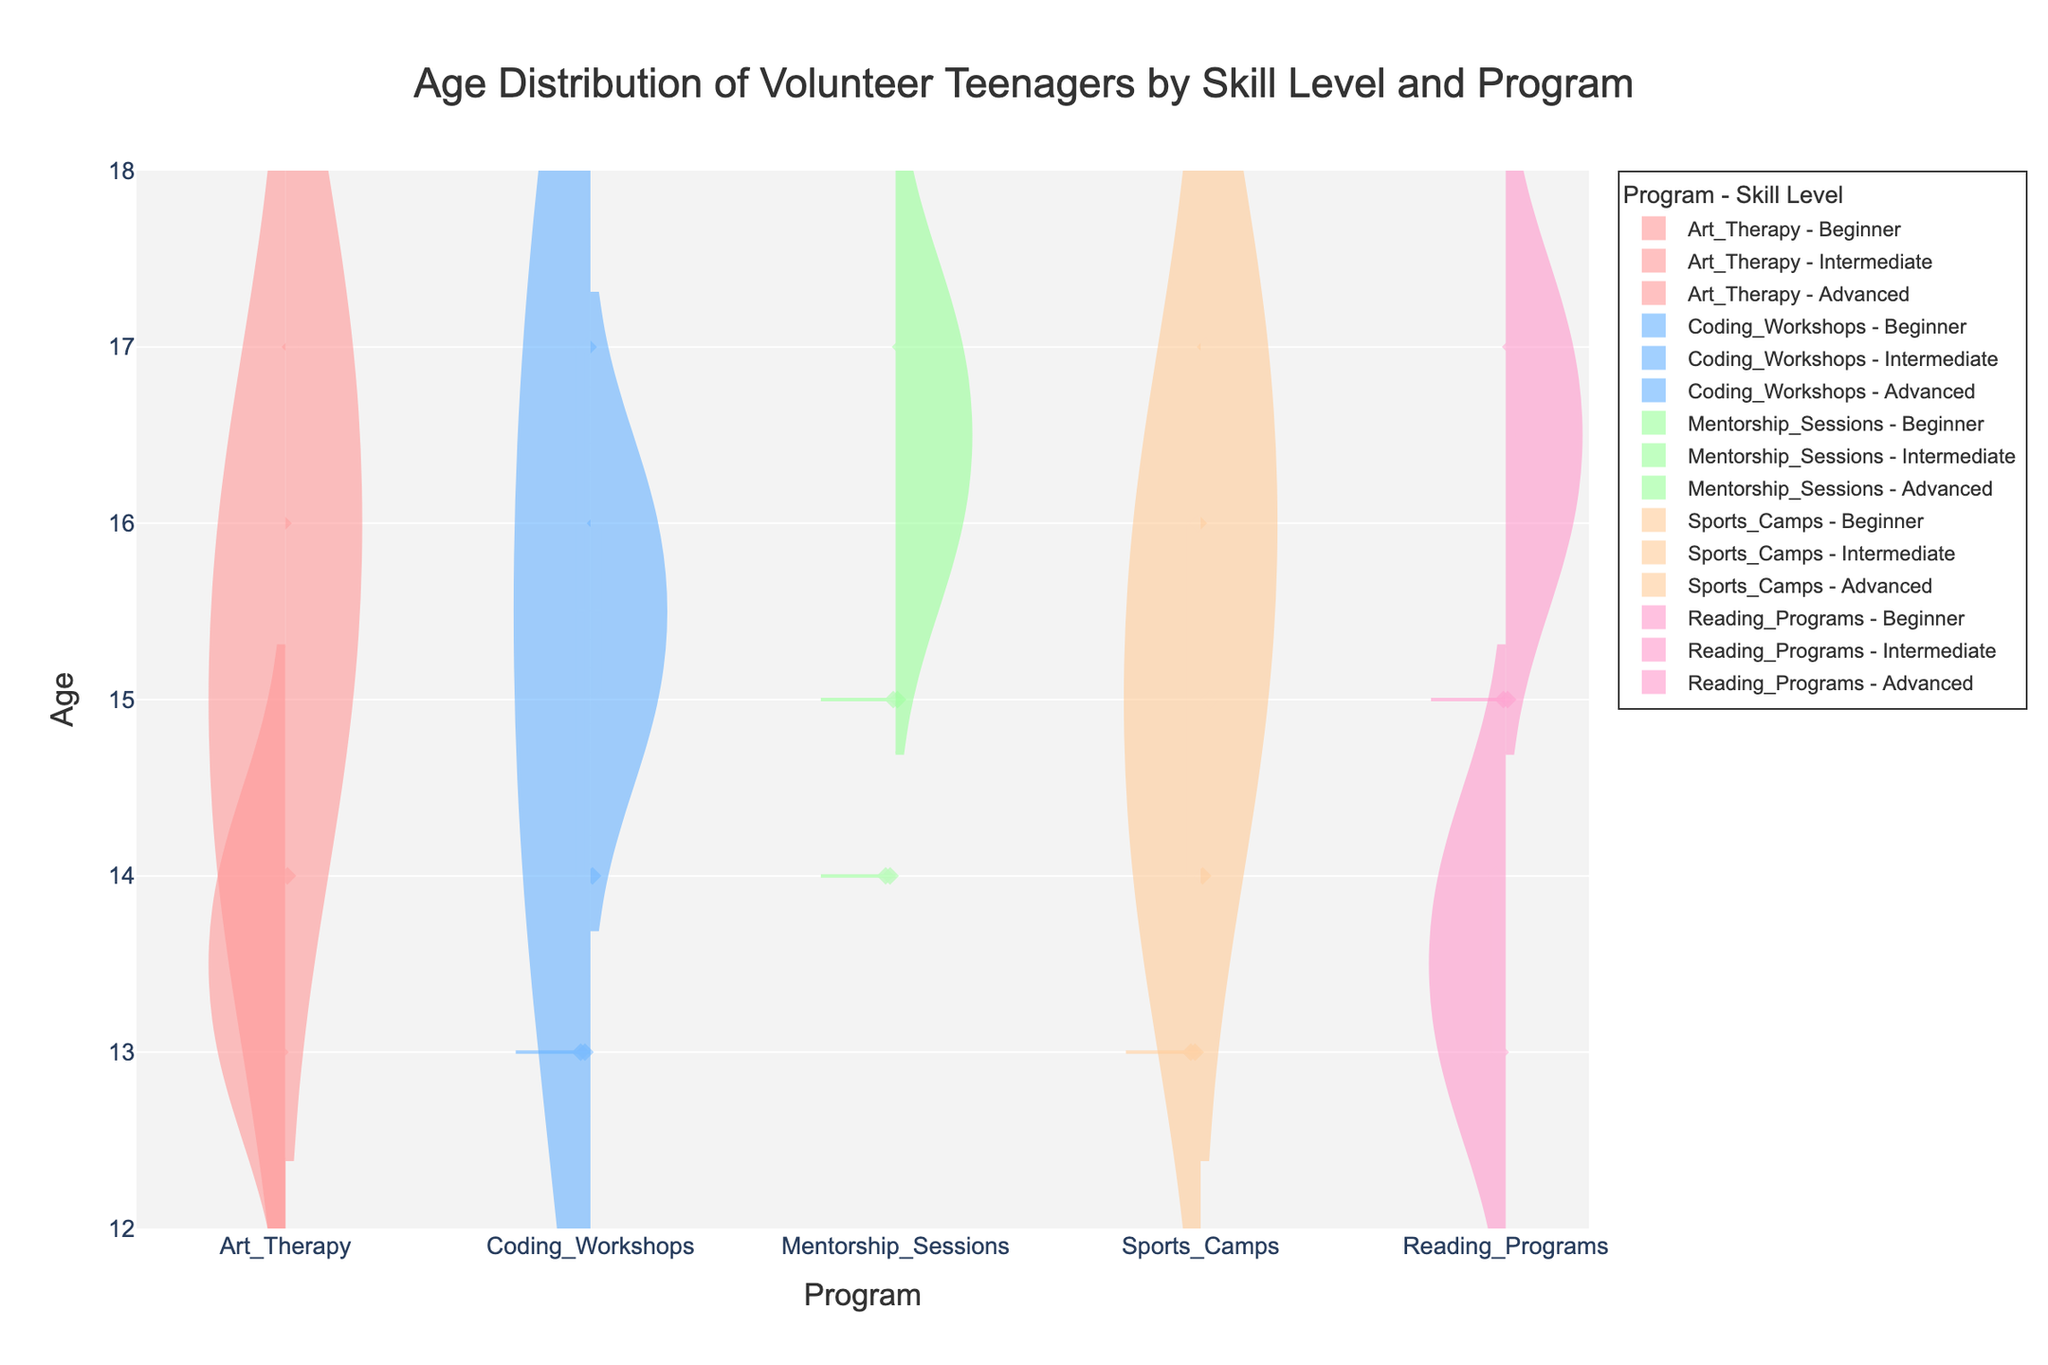What is the title of the chart? The title is usually displayed at the top of the chart, and it summarizes what the chart represents. In this case, the title is "Age Distribution of Volunteer Teenagers by Skill Level and Program".
Answer: Age Distribution of Volunteer Teenagers by Skill Level and Program How many different training programs are shown in the chart? To find the number of training programs, count the unique program names displayed on the x-axis. The programs are Art Therapy, Coding Workshops, Mentorship Sessions, Sports Camps, and Reading Programs.
Answer: 5 Which program has the youngest volunteer for the Beginner skill level? For each program and skill level, locate the lowest point of the violin plot representing Beginner skill level. The youngest volunteer for Beginner is 13, which appears in several programs, such as Art Therapy.
Answer: Art Therapy What is the age range for Advanced skill level in the Coding Workshops program? First, identify the violin plot for Advanced skill level under Coding Workshops. The age range is indicated by the spread of the plot from the minimum to maximum points. The range is from 15 to 16.
Answer: 15-16 Which program has the oldest volunteer at the Intermediate skill level? Check the highest points on the violin plots for Intermediate skill level across all programs. The oldest volunteer at Intermediate skill level is 17, visible in Coding Workshops and several other programs.
Answer: Coding Workshops What is the mean age of volunteers in the Reading Programs for the Beginner skill level? Mean age is marked by the middle line in the violin plot. For Beginner skill level in Reading Programs, observe the midpoint of the violin spread which hovers around ages 13 and 14.
Answer: Around 14 Are the age distributions for the Advanced skill level wider or narrower compared to the Beginner skill level in most programs? Examine the spread (width) of the violin plots for both Advanced and Beginner levels across programs. Generally, Advanced plots tend to have narrower distributions compared to the Beginner ones, which have broader spreads.
Answer: Narrower Which skill level has the most consistent age range across all programs? "Consistent age range" means small variation. By looking at the uniformity of vioplot spread across all five programs, Intermediate skill level shows the most similar spread across programs.
Answer: Intermediate In the Sports Camps program, what is the lowest age and highest age represented? Identify the lowest and highest points of the plots for Sports Camps across all skill levels. The lowest age represented is 13 (Beginner), and the highest is 17 (Advanced).
Answer: 13-17 